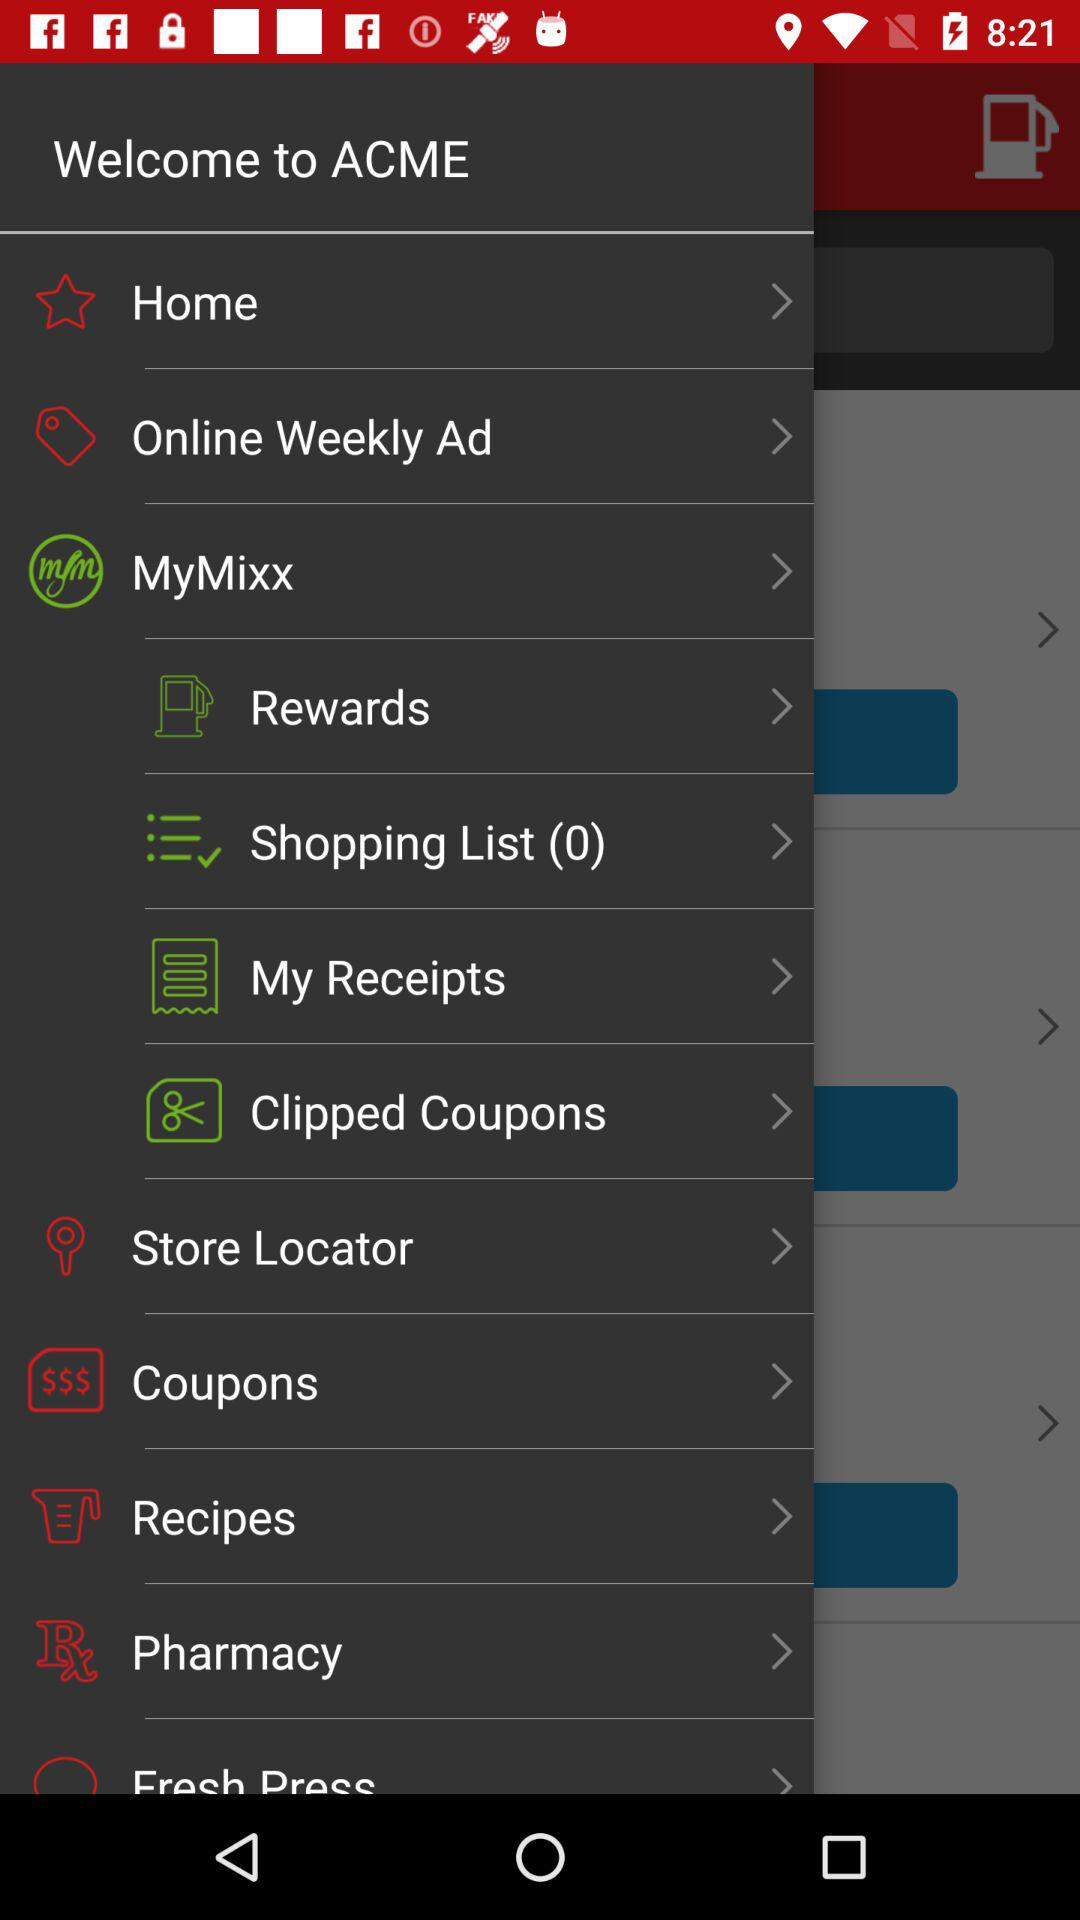What is the total number of items on the shopping list? The total number of items on the shopping list is 0. 